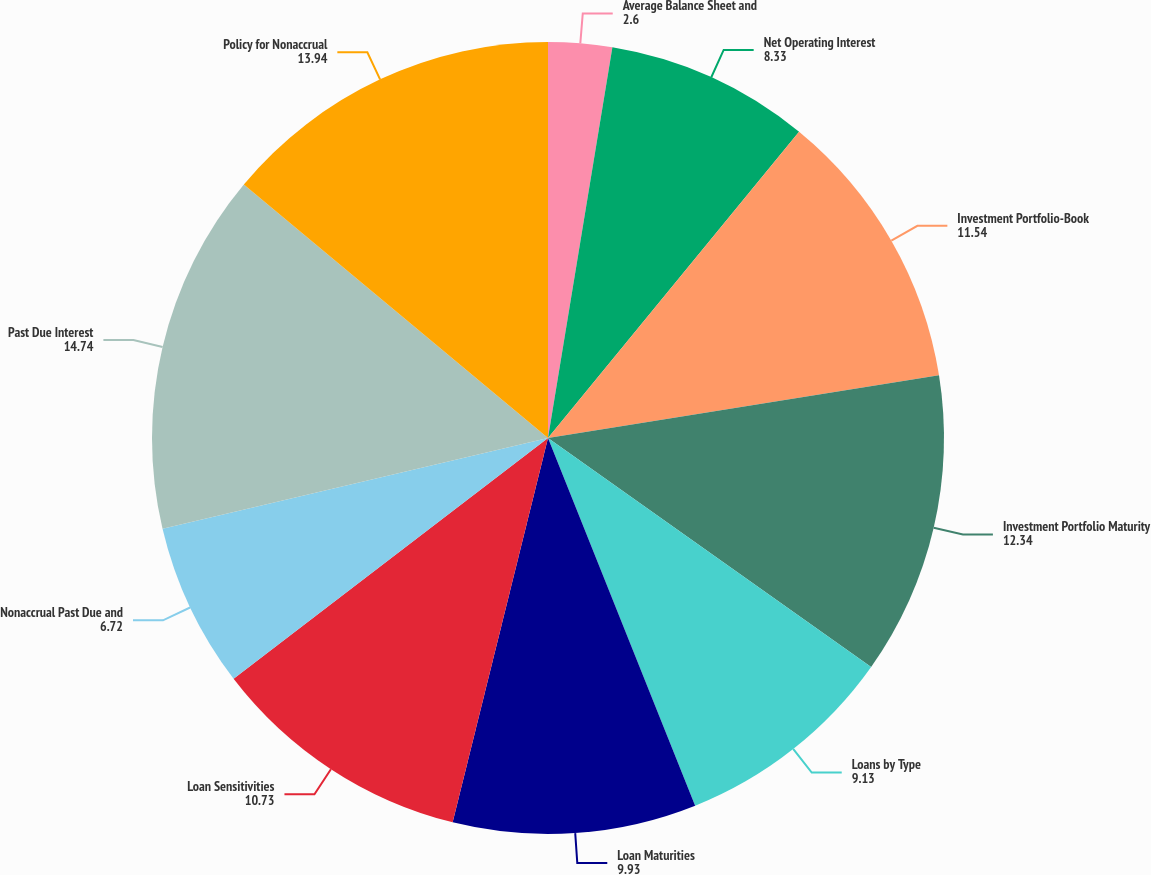Convert chart to OTSL. <chart><loc_0><loc_0><loc_500><loc_500><pie_chart><fcel>Average Balance Sheet and<fcel>Net Operating Interest<fcel>Investment Portfolio-Book<fcel>Investment Portfolio Maturity<fcel>Loans by Type<fcel>Loan Maturities<fcel>Loan Sensitivities<fcel>Nonaccrual Past Due and<fcel>Past Due Interest<fcel>Policy for Nonaccrual<nl><fcel>2.6%<fcel>8.33%<fcel>11.54%<fcel>12.34%<fcel>9.13%<fcel>9.93%<fcel>10.73%<fcel>6.72%<fcel>14.74%<fcel>13.94%<nl></chart> 